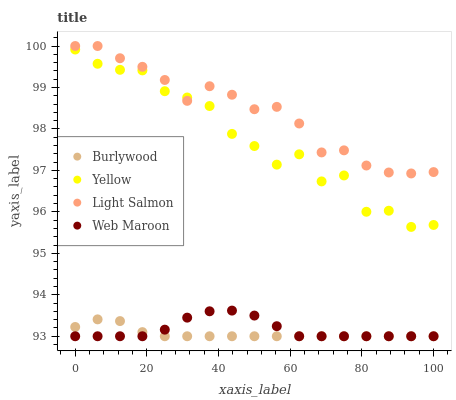Does Burlywood have the minimum area under the curve?
Answer yes or no. Yes. Does Light Salmon have the maximum area under the curve?
Answer yes or no. Yes. Does Web Maroon have the minimum area under the curve?
Answer yes or no. No. Does Web Maroon have the maximum area under the curve?
Answer yes or no. No. Is Burlywood the smoothest?
Answer yes or no. Yes. Is Yellow the roughest?
Answer yes or no. Yes. Is Light Salmon the smoothest?
Answer yes or no. No. Is Light Salmon the roughest?
Answer yes or no. No. Does Burlywood have the lowest value?
Answer yes or no. Yes. Does Light Salmon have the lowest value?
Answer yes or no. No. Does Light Salmon have the highest value?
Answer yes or no. Yes. Does Web Maroon have the highest value?
Answer yes or no. No. Is Burlywood less than Yellow?
Answer yes or no. Yes. Is Light Salmon greater than Burlywood?
Answer yes or no. Yes. Does Yellow intersect Light Salmon?
Answer yes or no. Yes. Is Yellow less than Light Salmon?
Answer yes or no. No. Is Yellow greater than Light Salmon?
Answer yes or no. No. Does Burlywood intersect Yellow?
Answer yes or no. No. 